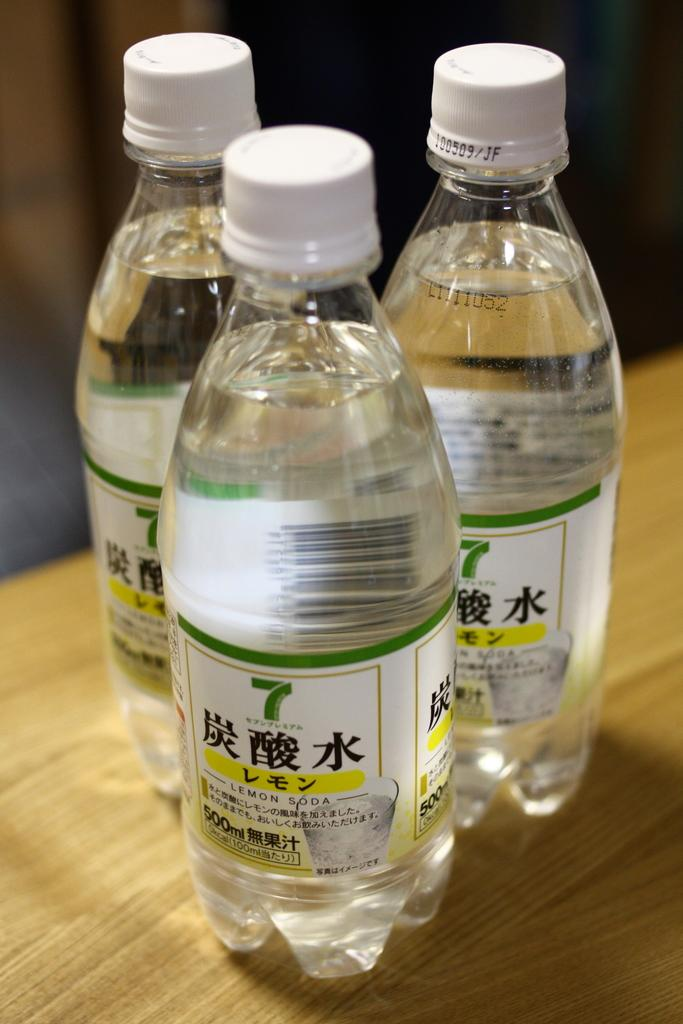<image>
Offer a succinct explanation of the picture presented. Three bottles of 7 lemon soda sit together on a wooden table. 